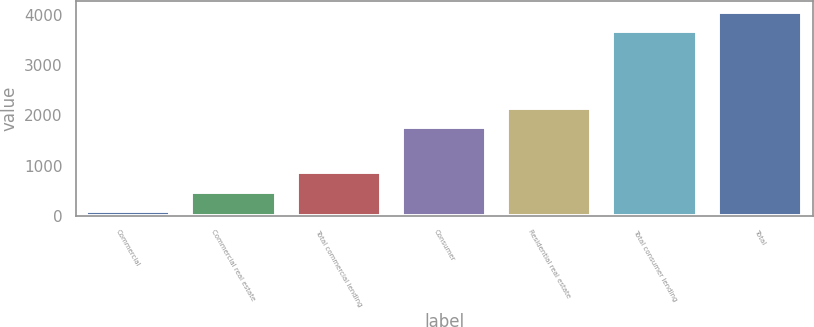<chart> <loc_0><loc_0><loc_500><loc_500><bar_chart><fcel>Commercial<fcel>Commercial real estate<fcel>Total commercial lending<fcel>Consumer<fcel>Residential real estate<fcel>Total consumer lending<fcel>Total<nl><fcel>94<fcel>477.9<fcel>861.8<fcel>1769<fcel>2152.9<fcel>3684<fcel>4067.9<nl></chart> 